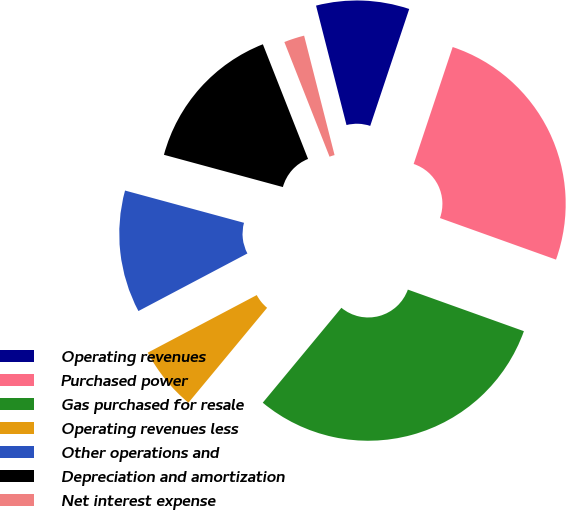Convert chart. <chart><loc_0><loc_0><loc_500><loc_500><pie_chart><fcel>Operating revenues<fcel>Purchased power<fcel>Gas purchased for resale<fcel>Operating revenues less<fcel>Other operations and<fcel>Depreciation and amortization<fcel>Net interest expense<nl><fcel>9.1%<fcel>25.35%<fcel>30.54%<fcel>6.25%<fcel>11.95%<fcel>14.81%<fcel>2.0%<nl></chart> 